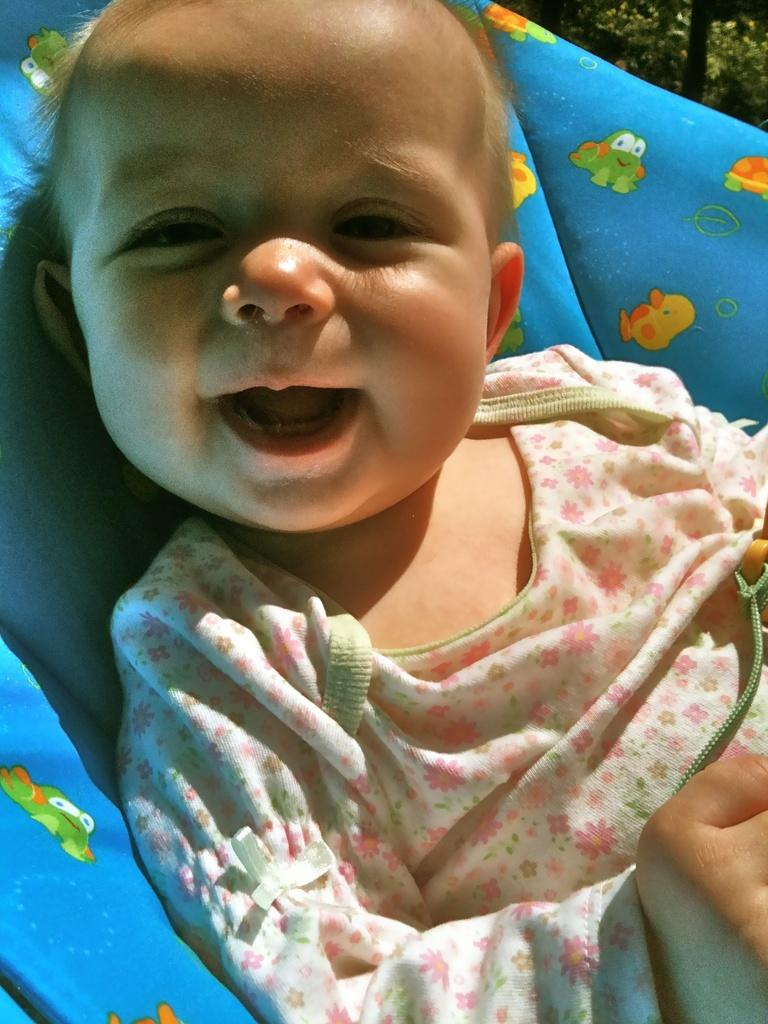What is the main subject of the image? There is a baby in the image. Where is the baby located? The baby is on a bed. What type of curtain is hanging near the baby in the image? There is no curtain present in the image; it only features a baby on a bed. 